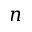Convert formula to latex. <formula><loc_0><loc_0><loc_500><loc_500>n</formula> 